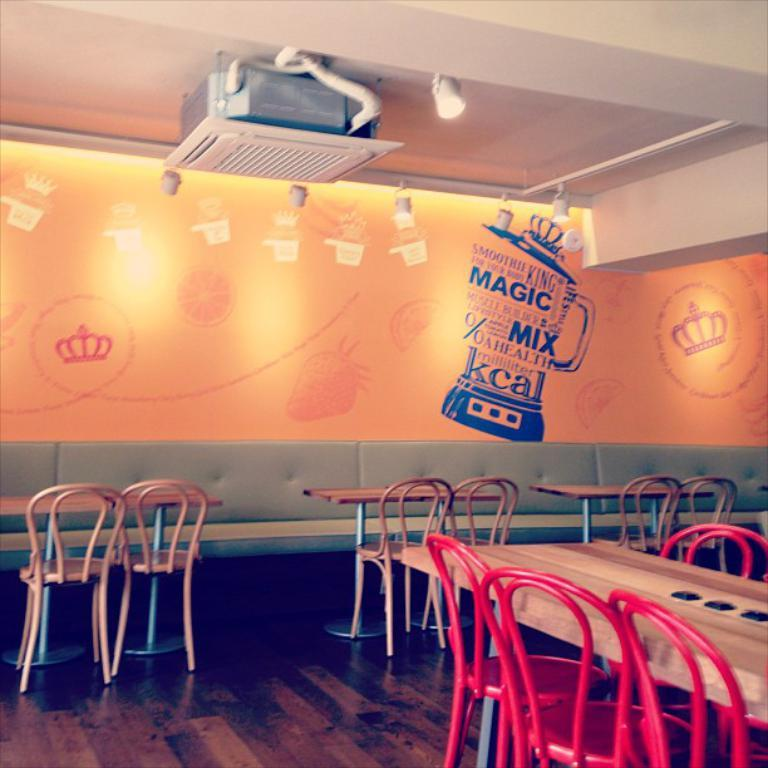What type of furniture is present in the image? There are chairs, tables, and sofas in the image. What can be seen on the floor in the image? The floor is visible in the image. What is hanging on the wall in the background? There is a painting on the wall in the background. What is located at the top of the image? There is a device and lights at the top of the image. What type of base is supporting the device at the top of the image? There is no base visible in the image; only the device and lights are present at the top. What type of smell can be detected in the image? There is no information about smells in the image, as it only provides visual details. 